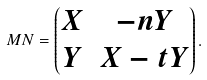Convert formula to latex. <formula><loc_0><loc_0><loc_500><loc_500>M N = \begin{pmatrix} X & - n Y \\ Y & X - t Y \end{pmatrix} .</formula> 